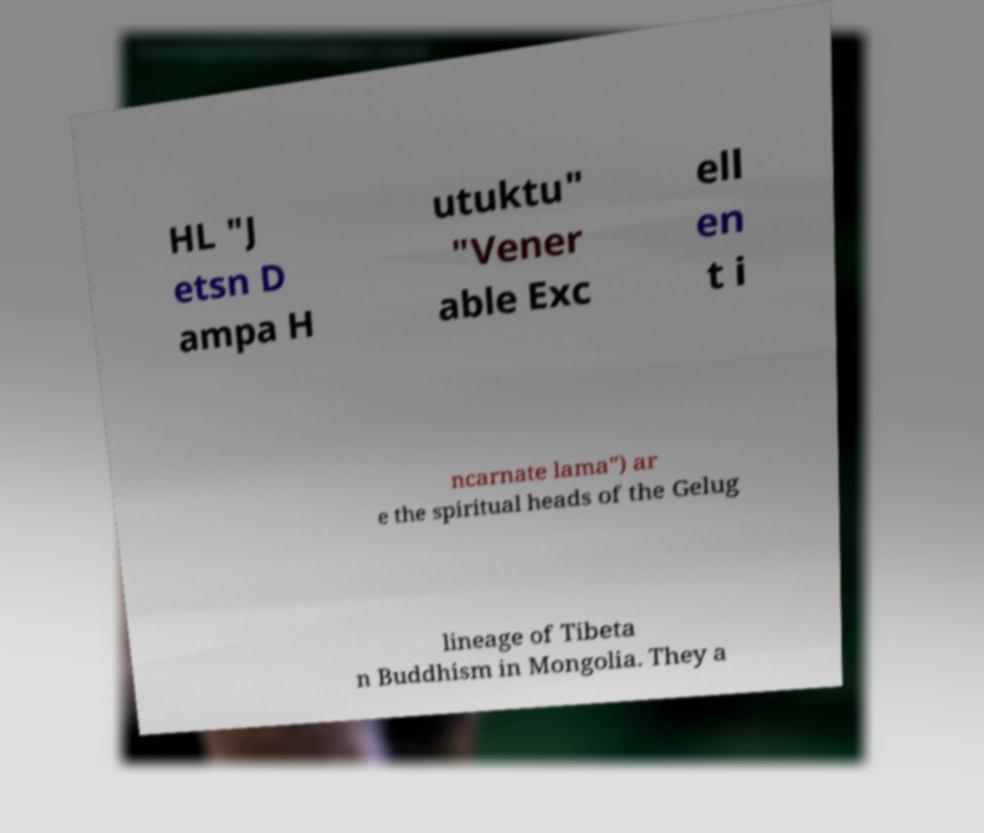For documentation purposes, I need the text within this image transcribed. Could you provide that? HL "J etsn D ampa H utuktu" "Vener able Exc ell en t i ncarnate lama") ar e the spiritual heads of the Gelug lineage of Tibeta n Buddhism in Mongolia. They a 